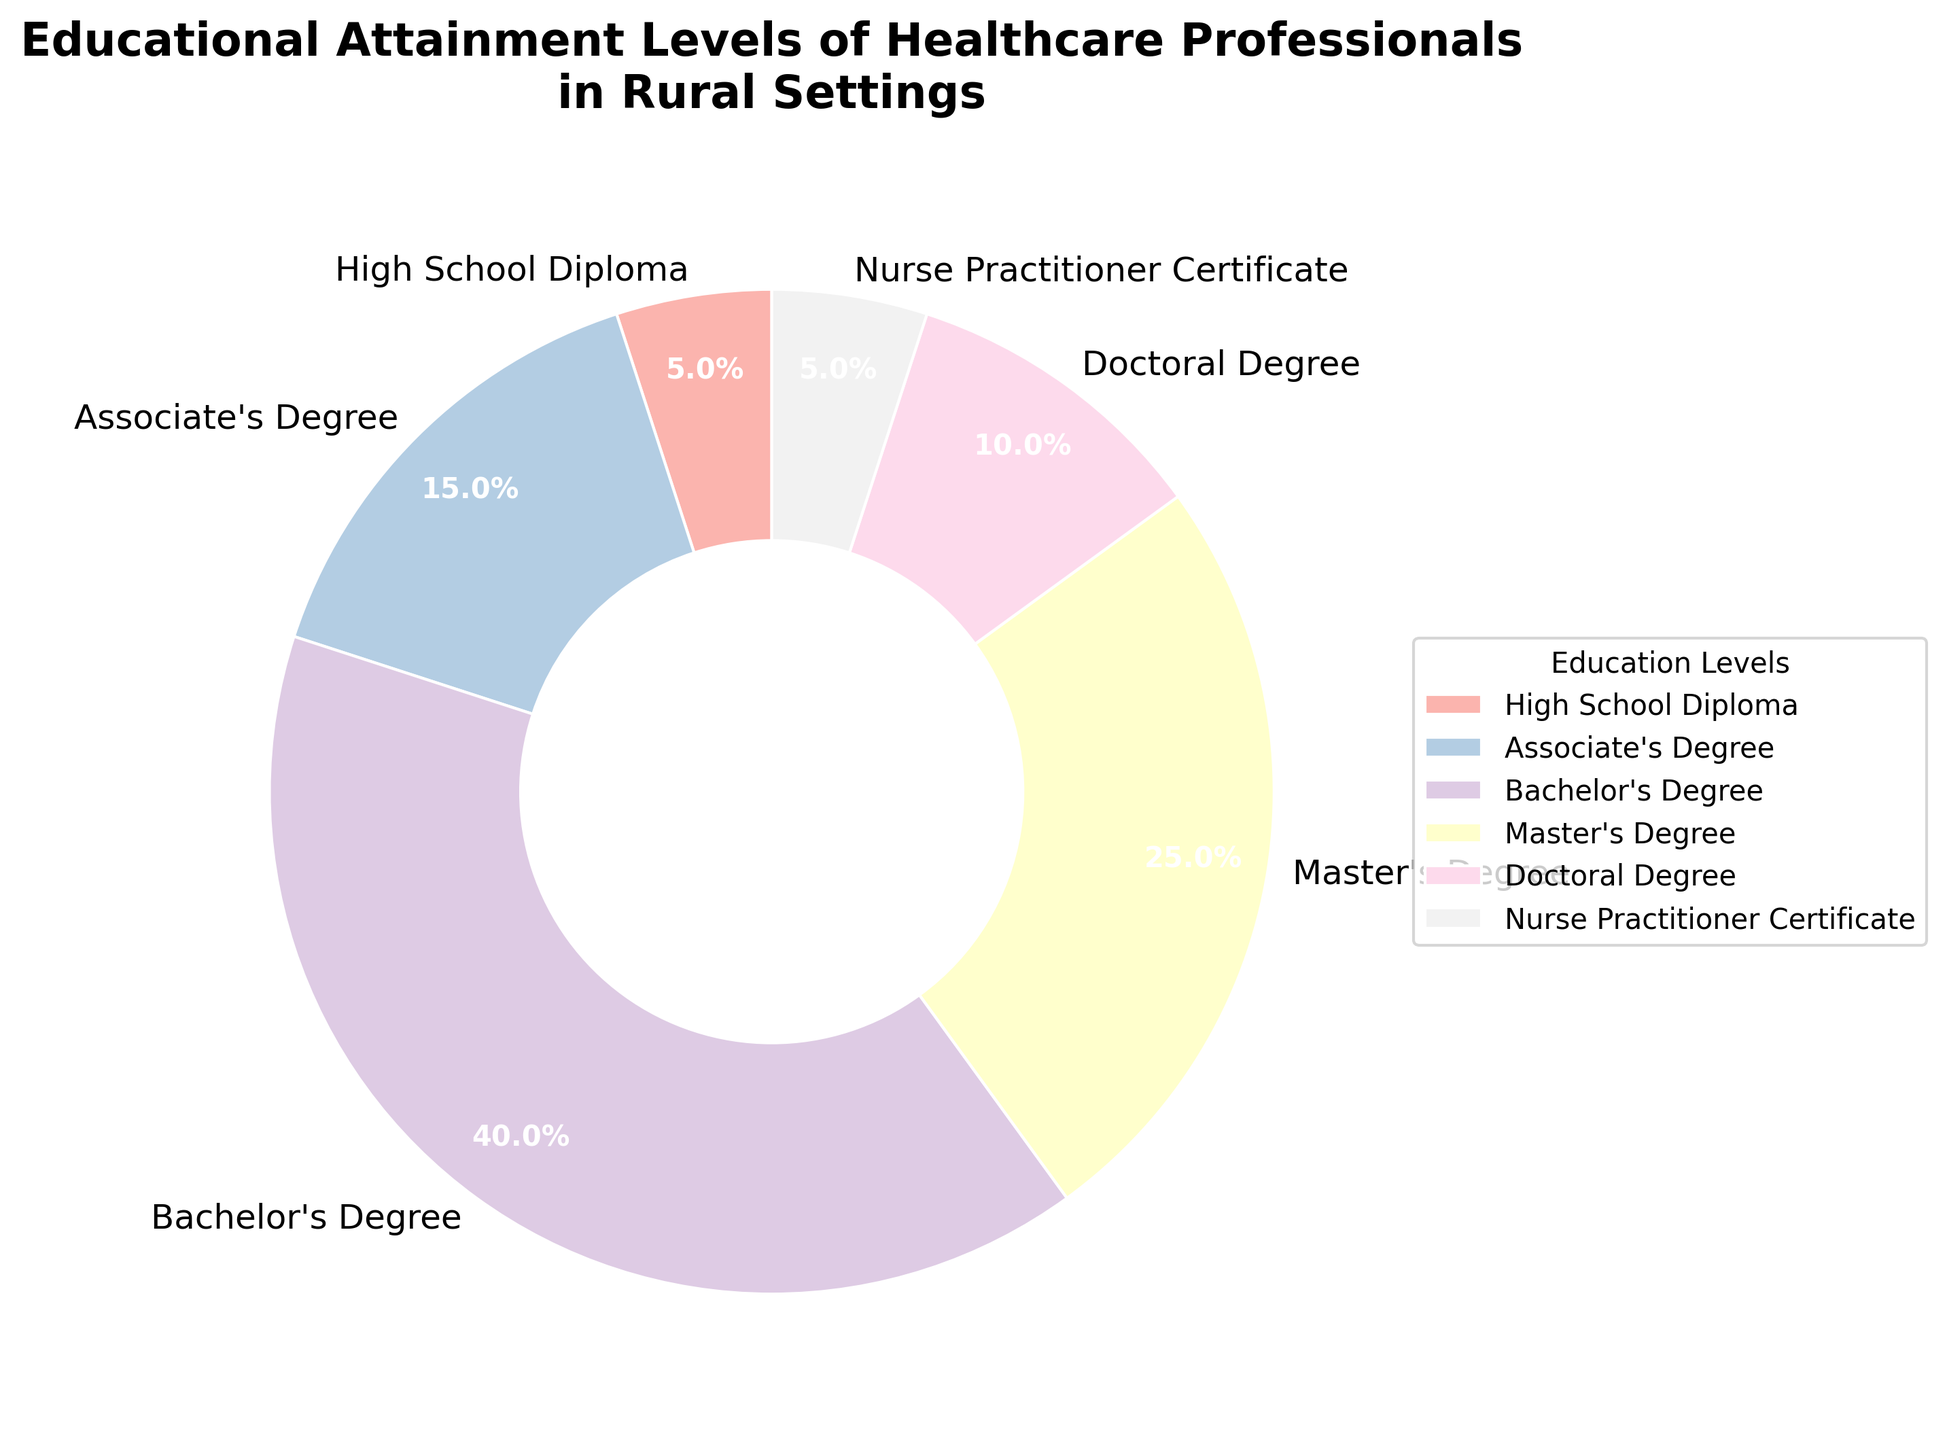What percentage of healthcare professionals in rural settings hold a Bachelor's Degree? The pie chart shows that 40% of healthcare professionals have a Bachelor's Degree. This can be directly read from the section labeled 'Bachelor's Degree'
Answer: 40% What is the combined percentage of healthcare professionals with a Master's or Doctoral Degree? The pie chart shows the percentage for a Master's Degree is 25% and for a Doctoral Degree is 10%. Adding these gives 25% + 10% = 35%
Answer: 35% Which education level has the lowest representation among healthcare professionals in rural settings? According to the pie chart, both 'High School Diploma' and 'Nurse Practitioner Certificate' have the lowest percentage, each at 5%.
Answer: High School Diploma, Nurse Practitioner Certificate By how much does the percentage of professionals with an Associate's Degree exceed those with a High School Diploma? The pie chart shows 15% for Associate's Degree and 5% for High School Diploma. The difference is 15% - 5% = 10%
Answer: 10% Which educational attainment level occupies the largest section of the pie chart? The section labeled 'Bachelor's Degree' occupies the largest part of the pie chart with 40%.
Answer: Bachelor's Degree Is the percentage of professionals with a Master’s Degree greater than the combined percentage of those with a High School Diploma and Nurse Practitioner Certificate? Professionals with a Master's Degree make up 25%. Combining those with a High School Diploma (5%) and Nurse Practitioner Certificate (5%) gives 5% + 5% = 10%. Since 25% > 10%, the percentage of Master's is greater.
Answer: Yes What is the color used to represent the Bachelor's Degree segment in the pie chart? The Bachelor's Degree segment is represented by the color designated by the 'Pastel1' colormap in matplotlib. This text specifically refers to identifying the color visually in the chart.
Answer: [interpret color visually based on chart] How does the percentage of healthcare professionals with a Doctoral Degree compare to those with an Associate's Degree? The pie chart shows 10% for Doctoral Degree and 15% for Associate's Degree. 10% < 15%, so the percentage with a Doctoral Degree is less.
Answer: Less What is the average percentage of healthcare professionals with an Associate's Degree, Master’s Degree, and Doctoral Degree? The percentages are 15%, 25%, and 10% respectively. The average is (15% + 25% + 10%)/3 = 50%/3 ≈ 16.67%
Answer: 16.67% 